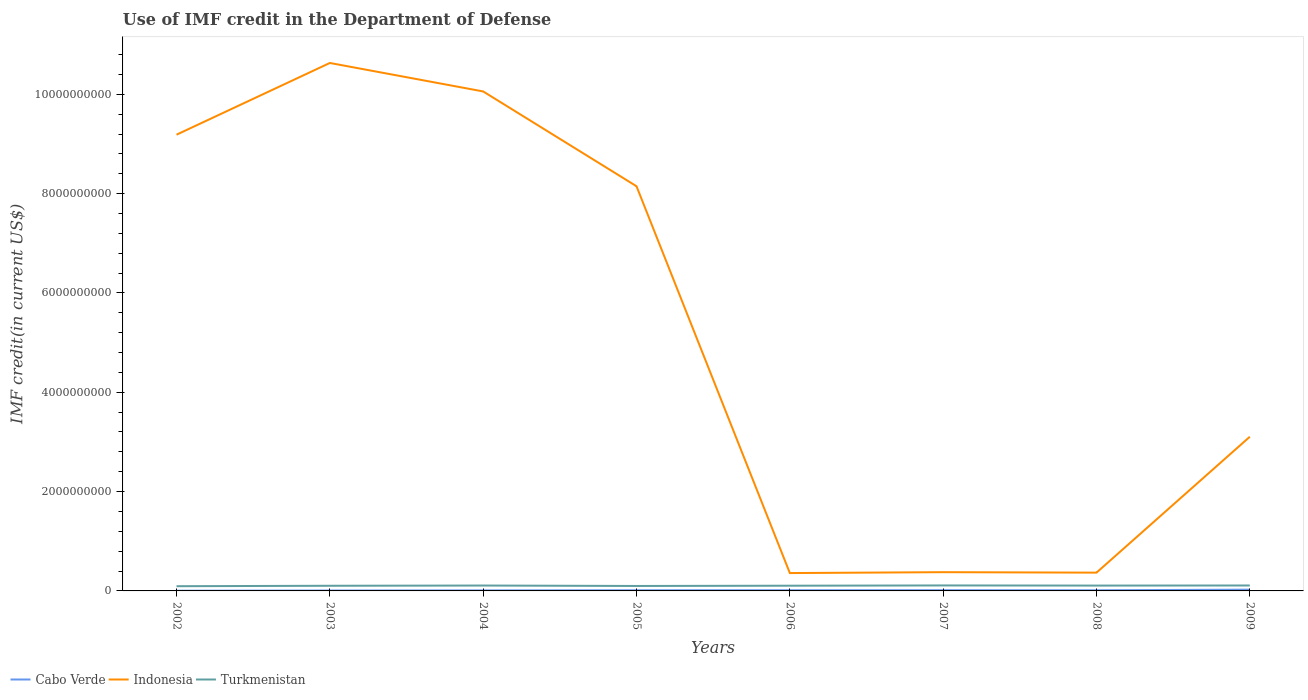Does the line corresponding to Indonesia intersect with the line corresponding to Turkmenistan?
Provide a short and direct response. No. Is the number of lines equal to the number of legend labels?
Make the answer very short. Yes. Across all years, what is the maximum IMF credit in the Department of Defense in Turkmenistan?
Your response must be concise. 9.49e+07. In which year was the IMF credit in the Department of Defense in Indonesia maximum?
Give a very brief answer. 2006. What is the total IMF credit in the Department of Defense in Indonesia in the graph?
Ensure brevity in your answer.  9.69e+09. What is the difference between the highest and the second highest IMF credit in the Department of Defense in Cabo Verde?
Your response must be concise. 2.12e+07. Is the IMF credit in the Department of Defense in Cabo Verde strictly greater than the IMF credit in the Department of Defense in Indonesia over the years?
Your answer should be very brief. Yes. How many lines are there?
Keep it short and to the point. 3. How many years are there in the graph?
Ensure brevity in your answer.  8. Are the values on the major ticks of Y-axis written in scientific E-notation?
Your response must be concise. No. Does the graph contain any zero values?
Keep it short and to the point. No. Does the graph contain grids?
Make the answer very short. No. What is the title of the graph?
Your answer should be very brief. Use of IMF credit in the Department of Defense. Does "San Marino" appear as one of the legend labels in the graph?
Provide a short and direct response. No. What is the label or title of the Y-axis?
Ensure brevity in your answer.  IMF credit(in current US$). What is the IMF credit(in current US$) in Cabo Verde in 2002?
Provide a short and direct response. 4.19e+06. What is the IMF credit(in current US$) in Indonesia in 2002?
Your answer should be compact. 9.19e+09. What is the IMF credit(in current US$) in Turkmenistan in 2002?
Provide a short and direct response. 9.49e+07. What is the IMF credit(in current US$) of Cabo Verde in 2003?
Your response must be concise. 8.23e+06. What is the IMF credit(in current US$) in Indonesia in 2003?
Provide a succinct answer. 1.06e+1. What is the IMF credit(in current US$) of Turkmenistan in 2003?
Give a very brief answer. 1.04e+08. What is the IMF credit(in current US$) in Cabo Verde in 2004?
Give a very brief answer. 1.05e+07. What is the IMF credit(in current US$) in Indonesia in 2004?
Offer a terse response. 1.01e+1. What is the IMF credit(in current US$) of Turkmenistan in 2004?
Provide a succinct answer. 1.08e+08. What is the IMF credit(in current US$) in Cabo Verde in 2005?
Make the answer very short. 1.32e+07. What is the IMF credit(in current US$) of Indonesia in 2005?
Your answer should be compact. 8.15e+09. What is the IMF credit(in current US$) of Turkmenistan in 2005?
Keep it short and to the point. 9.98e+07. What is the IMF credit(in current US$) in Cabo Verde in 2006?
Your answer should be compact. 1.39e+07. What is the IMF credit(in current US$) of Indonesia in 2006?
Ensure brevity in your answer.  3.59e+08. What is the IMF credit(in current US$) of Turkmenistan in 2006?
Provide a short and direct response. 1.05e+08. What is the IMF credit(in current US$) in Cabo Verde in 2007?
Provide a succinct answer. 1.44e+07. What is the IMF credit(in current US$) of Indonesia in 2007?
Your response must be concise. 3.78e+08. What is the IMF credit(in current US$) in Turkmenistan in 2007?
Ensure brevity in your answer.  1.10e+08. What is the IMF credit(in current US$) of Cabo Verde in 2008?
Your answer should be very brief. 1.33e+07. What is the IMF credit(in current US$) of Indonesia in 2008?
Your answer should be very brief. 3.68e+08. What is the IMF credit(in current US$) of Turkmenistan in 2008?
Make the answer very short. 1.08e+08. What is the IMF credit(in current US$) of Cabo Verde in 2009?
Your answer should be compact. 2.54e+07. What is the IMF credit(in current US$) of Indonesia in 2009?
Give a very brief answer. 3.10e+09. What is the IMF credit(in current US$) of Turkmenistan in 2009?
Ensure brevity in your answer.  1.09e+08. Across all years, what is the maximum IMF credit(in current US$) of Cabo Verde?
Provide a succinct answer. 2.54e+07. Across all years, what is the maximum IMF credit(in current US$) of Indonesia?
Offer a terse response. 1.06e+1. Across all years, what is the maximum IMF credit(in current US$) in Turkmenistan?
Your answer should be very brief. 1.10e+08. Across all years, what is the minimum IMF credit(in current US$) in Cabo Verde?
Offer a terse response. 4.19e+06. Across all years, what is the minimum IMF credit(in current US$) in Indonesia?
Ensure brevity in your answer.  3.59e+08. Across all years, what is the minimum IMF credit(in current US$) in Turkmenistan?
Ensure brevity in your answer.  9.49e+07. What is the total IMF credit(in current US$) of Cabo Verde in the graph?
Your answer should be very brief. 1.03e+08. What is the total IMF credit(in current US$) of Indonesia in the graph?
Keep it short and to the point. 4.22e+1. What is the total IMF credit(in current US$) in Turkmenistan in the graph?
Offer a terse response. 8.39e+08. What is the difference between the IMF credit(in current US$) in Cabo Verde in 2002 and that in 2003?
Your answer should be compact. -4.04e+06. What is the difference between the IMF credit(in current US$) of Indonesia in 2002 and that in 2003?
Provide a succinct answer. -1.44e+09. What is the difference between the IMF credit(in current US$) in Turkmenistan in 2002 and that in 2003?
Your response must be concise. -8.83e+06. What is the difference between the IMF credit(in current US$) of Cabo Verde in 2002 and that in 2004?
Make the answer very short. -6.33e+06. What is the difference between the IMF credit(in current US$) in Indonesia in 2002 and that in 2004?
Give a very brief answer. -8.71e+08. What is the difference between the IMF credit(in current US$) in Turkmenistan in 2002 and that in 2004?
Your answer should be very brief. -1.35e+07. What is the difference between the IMF credit(in current US$) of Cabo Verde in 2002 and that in 2005?
Your answer should be compact. -9.05e+06. What is the difference between the IMF credit(in current US$) in Indonesia in 2002 and that in 2005?
Your answer should be compact. 1.04e+09. What is the difference between the IMF credit(in current US$) of Turkmenistan in 2002 and that in 2005?
Your answer should be very brief. -4.87e+06. What is the difference between the IMF credit(in current US$) of Cabo Verde in 2002 and that in 2006?
Your answer should be very brief. -9.74e+06. What is the difference between the IMF credit(in current US$) of Indonesia in 2002 and that in 2006?
Your answer should be compact. 8.83e+09. What is the difference between the IMF credit(in current US$) in Turkmenistan in 2002 and that in 2006?
Keep it short and to the point. -1.01e+07. What is the difference between the IMF credit(in current US$) of Cabo Verde in 2002 and that in 2007?
Ensure brevity in your answer.  -1.03e+07. What is the difference between the IMF credit(in current US$) in Indonesia in 2002 and that in 2007?
Your response must be concise. 8.81e+09. What is the difference between the IMF credit(in current US$) of Turkmenistan in 2002 and that in 2007?
Keep it short and to the point. -1.54e+07. What is the difference between the IMF credit(in current US$) of Cabo Verde in 2002 and that in 2008?
Give a very brief answer. -9.13e+06. What is the difference between the IMF credit(in current US$) of Indonesia in 2002 and that in 2008?
Offer a very short reply. 8.82e+09. What is the difference between the IMF credit(in current US$) in Turkmenistan in 2002 and that in 2008?
Your answer should be very brief. -1.26e+07. What is the difference between the IMF credit(in current US$) in Cabo Verde in 2002 and that in 2009?
Make the answer very short. -2.12e+07. What is the difference between the IMF credit(in current US$) in Indonesia in 2002 and that in 2009?
Give a very brief answer. 6.08e+09. What is the difference between the IMF credit(in current US$) in Turkmenistan in 2002 and that in 2009?
Give a very brief answer. -1.45e+07. What is the difference between the IMF credit(in current US$) in Cabo Verde in 2003 and that in 2004?
Provide a succinct answer. -2.28e+06. What is the difference between the IMF credit(in current US$) in Indonesia in 2003 and that in 2004?
Keep it short and to the point. 5.73e+08. What is the difference between the IMF credit(in current US$) of Turkmenistan in 2003 and that in 2004?
Offer a very short reply. -4.68e+06. What is the difference between the IMF credit(in current US$) of Cabo Verde in 2003 and that in 2005?
Give a very brief answer. -5.00e+06. What is the difference between the IMF credit(in current US$) in Indonesia in 2003 and that in 2005?
Your answer should be compact. 2.48e+09. What is the difference between the IMF credit(in current US$) in Turkmenistan in 2003 and that in 2005?
Provide a succinct answer. 3.96e+06. What is the difference between the IMF credit(in current US$) in Cabo Verde in 2003 and that in 2006?
Your answer should be very brief. -5.70e+06. What is the difference between the IMF credit(in current US$) in Indonesia in 2003 and that in 2006?
Keep it short and to the point. 1.03e+1. What is the difference between the IMF credit(in current US$) of Turkmenistan in 2003 and that in 2006?
Ensure brevity in your answer.  -1.29e+06. What is the difference between the IMF credit(in current US$) of Cabo Verde in 2003 and that in 2007?
Offer a very short reply. -6.21e+06. What is the difference between the IMF credit(in current US$) in Indonesia in 2003 and that in 2007?
Your response must be concise. 1.03e+1. What is the difference between the IMF credit(in current US$) in Turkmenistan in 2003 and that in 2007?
Ensure brevity in your answer.  -6.58e+06. What is the difference between the IMF credit(in current US$) in Cabo Verde in 2003 and that in 2008?
Keep it short and to the point. -5.08e+06. What is the difference between the IMF credit(in current US$) of Indonesia in 2003 and that in 2008?
Your answer should be compact. 1.03e+1. What is the difference between the IMF credit(in current US$) of Turkmenistan in 2003 and that in 2008?
Offer a terse response. -3.79e+06. What is the difference between the IMF credit(in current US$) of Cabo Verde in 2003 and that in 2009?
Your answer should be very brief. -1.72e+07. What is the difference between the IMF credit(in current US$) of Indonesia in 2003 and that in 2009?
Provide a succinct answer. 7.53e+09. What is the difference between the IMF credit(in current US$) in Turkmenistan in 2003 and that in 2009?
Give a very brief answer. -5.70e+06. What is the difference between the IMF credit(in current US$) in Cabo Verde in 2004 and that in 2005?
Make the answer very short. -2.72e+06. What is the difference between the IMF credit(in current US$) in Indonesia in 2004 and that in 2005?
Ensure brevity in your answer.  1.91e+09. What is the difference between the IMF credit(in current US$) in Turkmenistan in 2004 and that in 2005?
Your answer should be compact. 8.64e+06. What is the difference between the IMF credit(in current US$) in Cabo Verde in 2004 and that in 2006?
Provide a short and direct response. -3.42e+06. What is the difference between the IMF credit(in current US$) in Indonesia in 2004 and that in 2006?
Ensure brevity in your answer.  9.70e+09. What is the difference between the IMF credit(in current US$) in Turkmenistan in 2004 and that in 2006?
Your response must be concise. 3.39e+06. What is the difference between the IMF credit(in current US$) in Cabo Verde in 2004 and that in 2007?
Offer a terse response. -3.92e+06. What is the difference between the IMF credit(in current US$) of Indonesia in 2004 and that in 2007?
Offer a terse response. 9.68e+09. What is the difference between the IMF credit(in current US$) of Turkmenistan in 2004 and that in 2007?
Ensure brevity in your answer.  -1.90e+06. What is the difference between the IMF credit(in current US$) in Cabo Verde in 2004 and that in 2008?
Make the answer very short. -2.80e+06. What is the difference between the IMF credit(in current US$) of Indonesia in 2004 and that in 2008?
Ensure brevity in your answer.  9.69e+09. What is the difference between the IMF credit(in current US$) of Turkmenistan in 2004 and that in 2008?
Make the answer very short. 8.89e+05. What is the difference between the IMF credit(in current US$) of Cabo Verde in 2004 and that in 2009?
Provide a succinct answer. -1.49e+07. What is the difference between the IMF credit(in current US$) of Indonesia in 2004 and that in 2009?
Your answer should be very brief. 6.95e+09. What is the difference between the IMF credit(in current US$) of Turkmenistan in 2004 and that in 2009?
Provide a succinct answer. -1.02e+06. What is the difference between the IMF credit(in current US$) in Cabo Verde in 2005 and that in 2006?
Your response must be concise. -6.96e+05. What is the difference between the IMF credit(in current US$) in Indonesia in 2005 and that in 2006?
Provide a short and direct response. 7.79e+09. What is the difference between the IMF credit(in current US$) in Turkmenistan in 2005 and that in 2006?
Offer a very short reply. -5.24e+06. What is the difference between the IMF credit(in current US$) of Cabo Verde in 2005 and that in 2007?
Offer a terse response. -1.20e+06. What is the difference between the IMF credit(in current US$) of Indonesia in 2005 and that in 2007?
Provide a succinct answer. 7.77e+09. What is the difference between the IMF credit(in current US$) in Turkmenistan in 2005 and that in 2007?
Your answer should be very brief. -1.05e+07. What is the difference between the IMF credit(in current US$) of Cabo Verde in 2005 and that in 2008?
Your response must be concise. -8.10e+04. What is the difference between the IMF credit(in current US$) of Indonesia in 2005 and that in 2008?
Keep it short and to the point. 7.78e+09. What is the difference between the IMF credit(in current US$) of Turkmenistan in 2005 and that in 2008?
Your answer should be very brief. -7.75e+06. What is the difference between the IMF credit(in current US$) of Cabo Verde in 2005 and that in 2009?
Offer a very short reply. -1.22e+07. What is the difference between the IMF credit(in current US$) of Indonesia in 2005 and that in 2009?
Provide a short and direct response. 5.04e+09. What is the difference between the IMF credit(in current US$) of Turkmenistan in 2005 and that in 2009?
Make the answer very short. -9.66e+06. What is the difference between the IMF credit(in current US$) of Cabo Verde in 2006 and that in 2007?
Your answer should be compact. -5.08e+05. What is the difference between the IMF credit(in current US$) in Indonesia in 2006 and that in 2007?
Give a very brief answer. -1.81e+07. What is the difference between the IMF credit(in current US$) of Turkmenistan in 2006 and that in 2007?
Ensure brevity in your answer.  -5.30e+06. What is the difference between the IMF credit(in current US$) of Cabo Verde in 2006 and that in 2008?
Your answer should be very brief. 6.15e+05. What is the difference between the IMF credit(in current US$) of Indonesia in 2006 and that in 2008?
Your answer should be compact. -8.57e+06. What is the difference between the IMF credit(in current US$) of Turkmenistan in 2006 and that in 2008?
Keep it short and to the point. -2.50e+06. What is the difference between the IMF credit(in current US$) in Cabo Verde in 2006 and that in 2009?
Offer a terse response. -1.15e+07. What is the difference between the IMF credit(in current US$) of Indonesia in 2006 and that in 2009?
Provide a succinct answer. -2.75e+09. What is the difference between the IMF credit(in current US$) in Turkmenistan in 2006 and that in 2009?
Offer a very short reply. -4.42e+06. What is the difference between the IMF credit(in current US$) in Cabo Verde in 2007 and that in 2008?
Offer a very short reply. 1.12e+06. What is the difference between the IMF credit(in current US$) in Indonesia in 2007 and that in 2008?
Offer a terse response. 9.55e+06. What is the difference between the IMF credit(in current US$) of Turkmenistan in 2007 and that in 2008?
Your answer should be very brief. 2.79e+06. What is the difference between the IMF credit(in current US$) in Cabo Verde in 2007 and that in 2009?
Your answer should be very brief. -1.10e+07. What is the difference between the IMF credit(in current US$) in Indonesia in 2007 and that in 2009?
Provide a succinct answer. -2.73e+09. What is the difference between the IMF credit(in current US$) in Turkmenistan in 2007 and that in 2009?
Your answer should be compact. 8.77e+05. What is the difference between the IMF credit(in current US$) of Cabo Verde in 2008 and that in 2009?
Ensure brevity in your answer.  -1.21e+07. What is the difference between the IMF credit(in current US$) of Indonesia in 2008 and that in 2009?
Offer a very short reply. -2.74e+09. What is the difference between the IMF credit(in current US$) in Turkmenistan in 2008 and that in 2009?
Your answer should be compact. -1.91e+06. What is the difference between the IMF credit(in current US$) of Cabo Verde in 2002 and the IMF credit(in current US$) of Indonesia in 2003?
Your answer should be compact. -1.06e+1. What is the difference between the IMF credit(in current US$) in Cabo Verde in 2002 and the IMF credit(in current US$) in Turkmenistan in 2003?
Give a very brief answer. -9.96e+07. What is the difference between the IMF credit(in current US$) of Indonesia in 2002 and the IMF credit(in current US$) of Turkmenistan in 2003?
Your response must be concise. 9.08e+09. What is the difference between the IMF credit(in current US$) of Cabo Verde in 2002 and the IMF credit(in current US$) of Indonesia in 2004?
Provide a short and direct response. -1.01e+1. What is the difference between the IMF credit(in current US$) in Cabo Verde in 2002 and the IMF credit(in current US$) in Turkmenistan in 2004?
Keep it short and to the point. -1.04e+08. What is the difference between the IMF credit(in current US$) of Indonesia in 2002 and the IMF credit(in current US$) of Turkmenistan in 2004?
Make the answer very short. 9.08e+09. What is the difference between the IMF credit(in current US$) in Cabo Verde in 2002 and the IMF credit(in current US$) in Indonesia in 2005?
Provide a succinct answer. -8.14e+09. What is the difference between the IMF credit(in current US$) in Cabo Verde in 2002 and the IMF credit(in current US$) in Turkmenistan in 2005?
Provide a succinct answer. -9.56e+07. What is the difference between the IMF credit(in current US$) of Indonesia in 2002 and the IMF credit(in current US$) of Turkmenistan in 2005?
Ensure brevity in your answer.  9.09e+09. What is the difference between the IMF credit(in current US$) of Cabo Verde in 2002 and the IMF credit(in current US$) of Indonesia in 2006?
Ensure brevity in your answer.  -3.55e+08. What is the difference between the IMF credit(in current US$) in Cabo Verde in 2002 and the IMF credit(in current US$) in Turkmenistan in 2006?
Your answer should be very brief. -1.01e+08. What is the difference between the IMF credit(in current US$) in Indonesia in 2002 and the IMF credit(in current US$) in Turkmenistan in 2006?
Make the answer very short. 9.08e+09. What is the difference between the IMF credit(in current US$) of Cabo Verde in 2002 and the IMF credit(in current US$) of Indonesia in 2007?
Your answer should be very brief. -3.73e+08. What is the difference between the IMF credit(in current US$) of Cabo Verde in 2002 and the IMF credit(in current US$) of Turkmenistan in 2007?
Your answer should be compact. -1.06e+08. What is the difference between the IMF credit(in current US$) in Indonesia in 2002 and the IMF credit(in current US$) in Turkmenistan in 2007?
Your response must be concise. 9.08e+09. What is the difference between the IMF credit(in current US$) in Cabo Verde in 2002 and the IMF credit(in current US$) in Indonesia in 2008?
Offer a very short reply. -3.64e+08. What is the difference between the IMF credit(in current US$) of Cabo Verde in 2002 and the IMF credit(in current US$) of Turkmenistan in 2008?
Keep it short and to the point. -1.03e+08. What is the difference between the IMF credit(in current US$) in Indonesia in 2002 and the IMF credit(in current US$) in Turkmenistan in 2008?
Keep it short and to the point. 9.08e+09. What is the difference between the IMF credit(in current US$) in Cabo Verde in 2002 and the IMF credit(in current US$) in Indonesia in 2009?
Keep it short and to the point. -3.10e+09. What is the difference between the IMF credit(in current US$) in Cabo Verde in 2002 and the IMF credit(in current US$) in Turkmenistan in 2009?
Ensure brevity in your answer.  -1.05e+08. What is the difference between the IMF credit(in current US$) in Indonesia in 2002 and the IMF credit(in current US$) in Turkmenistan in 2009?
Provide a succinct answer. 9.08e+09. What is the difference between the IMF credit(in current US$) of Cabo Verde in 2003 and the IMF credit(in current US$) of Indonesia in 2004?
Provide a succinct answer. -1.00e+1. What is the difference between the IMF credit(in current US$) in Cabo Verde in 2003 and the IMF credit(in current US$) in Turkmenistan in 2004?
Provide a short and direct response. -1.00e+08. What is the difference between the IMF credit(in current US$) in Indonesia in 2003 and the IMF credit(in current US$) in Turkmenistan in 2004?
Keep it short and to the point. 1.05e+1. What is the difference between the IMF credit(in current US$) of Cabo Verde in 2003 and the IMF credit(in current US$) of Indonesia in 2005?
Offer a very short reply. -8.14e+09. What is the difference between the IMF credit(in current US$) in Cabo Verde in 2003 and the IMF credit(in current US$) in Turkmenistan in 2005?
Ensure brevity in your answer.  -9.16e+07. What is the difference between the IMF credit(in current US$) of Indonesia in 2003 and the IMF credit(in current US$) of Turkmenistan in 2005?
Give a very brief answer. 1.05e+1. What is the difference between the IMF credit(in current US$) in Cabo Verde in 2003 and the IMF credit(in current US$) in Indonesia in 2006?
Make the answer very short. -3.51e+08. What is the difference between the IMF credit(in current US$) of Cabo Verde in 2003 and the IMF credit(in current US$) of Turkmenistan in 2006?
Make the answer very short. -9.68e+07. What is the difference between the IMF credit(in current US$) in Indonesia in 2003 and the IMF credit(in current US$) in Turkmenistan in 2006?
Your answer should be very brief. 1.05e+1. What is the difference between the IMF credit(in current US$) in Cabo Verde in 2003 and the IMF credit(in current US$) in Indonesia in 2007?
Provide a short and direct response. -3.69e+08. What is the difference between the IMF credit(in current US$) in Cabo Verde in 2003 and the IMF credit(in current US$) in Turkmenistan in 2007?
Offer a terse response. -1.02e+08. What is the difference between the IMF credit(in current US$) of Indonesia in 2003 and the IMF credit(in current US$) of Turkmenistan in 2007?
Your response must be concise. 1.05e+1. What is the difference between the IMF credit(in current US$) of Cabo Verde in 2003 and the IMF credit(in current US$) of Indonesia in 2008?
Offer a terse response. -3.60e+08. What is the difference between the IMF credit(in current US$) of Cabo Verde in 2003 and the IMF credit(in current US$) of Turkmenistan in 2008?
Ensure brevity in your answer.  -9.93e+07. What is the difference between the IMF credit(in current US$) of Indonesia in 2003 and the IMF credit(in current US$) of Turkmenistan in 2008?
Provide a short and direct response. 1.05e+1. What is the difference between the IMF credit(in current US$) of Cabo Verde in 2003 and the IMF credit(in current US$) of Indonesia in 2009?
Give a very brief answer. -3.10e+09. What is the difference between the IMF credit(in current US$) in Cabo Verde in 2003 and the IMF credit(in current US$) in Turkmenistan in 2009?
Your answer should be compact. -1.01e+08. What is the difference between the IMF credit(in current US$) in Indonesia in 2003 and the IMF credit(in current US$) in Turkmenistan in 2009?
Your response must be concise. 1.05e+1. What is the difference between the IMF credit(in current US$) of Cabo Verde in 2004 and the IMF credit(in current US$) of Indonesia in 2005?
Give a very brief answer. -8.14e+09. What is the difference between the IMF credit(in current US$) of Cabo Verde in 2004 and the IMF credit(in current US$) of Turkmenistan in 2005?
Your answer should be very brief. -8.93e+07. What is the difference between the IMF credit(in current US$) in Indonesia in 2004 and the IMF credit(in current US$) in Turkmenistan in 2005?
Keep it short and to the point. 9.96e+09. What is the difference between the IMF credit(in current US$) in Cabo Verde in 2004 and the IMF credit(in current US$) in Indonesia in 2006?
Provide a succinct answer. -3.49e+08. What is the difference between the IMF credit(in current US$) of Cabo Verde in 2004 and the IMF credit(in current US$) of Turkmenistan in 2006?
Offer a terse response. -9.45e+07. What is the difference between the IMF credit(in current US$) of Indonesia in 2004 and the IMF credit(in current US$) of Turkmenistan in 2006?
Make the answer very short. 9.95e+09. What is the difference between the IMF credit(in current US$) in Cabo Verde in 2004 and the IMF credit(in current US$) in Indonesia in 2007?
Keep it short and to the point. -3.67e+08. What is the difference between the IMF credit(in current US$) of Cabo Verde in 2004 and the IMF credit(in current US$) of Turkmenistan in 2007?
Provide a short and direct response. -9.98e+07. What is the difference between the IMF credit(in current US$) in Indonesia in 2004 and the IMF credit(in current US$) in Turkmenistan in 2007?
Provide a succinct answer. 9.95e+09. What is the difference between the IMF credit(in current US$) in Cabo Verde in 2004 and the IMF credit(in current US$) in Indonesia in 2008?
Give a very brief answer. -3.58e+08. What is the difference between the IMF credit(in current US$) of Cabo Verde in 2004 and the IMF credit(in current US$) of Turkmenistan in 2008?
Keep it short and to the point. -9.70e+07. What is the difference between the IMF credit(in current US$) in Indonesia in 2004 and the IMF credit(in current US$) in Turkmenistan in 2008?
Keep it short and to the point. 9.95e+09. What is the difference between the IMF credit(in current US$) in Cabo Verde in 2004 and the IMF credit(in current US$) in Indonesia in 2009?
Ensure brevity in your answer.  -3.09e+09. What is the difference between the IMF credit(in current US$) of Cabo Verde in 2004 and the IMF credit(in current US$) of Turkmenistan in 2009?
Make the answer very short. -9.89e+07. What is the difference between the IMF credit(in current US$) of Indonesia in 2004 and the IMF credit(in current US$) of Turkmenistan in 2009?
Give a very brief answer. 9.95e+09. What is the difference between the IMF credit(in current US$) of Cabo Verde in 2005 and the IMF credit(in current US$) of Indonesia in 2006?
Your answer should be compact. -3.46e+08. What is the difference between the IMF credit(in current US$) of Cabo Verde in 2005 and the IMF credit(in current US$) of Turkmenistan in 2006?
Provide a short and direct response. -9.18e+07. What is the difference between the IMF credit(in current US$) of Indonesia in 2005 and the IMF credit(in current US$) of Turkmenistan in 2006?
Offer a terse response. 8.04e+09. What is the difference between the IMF credit(in current US$) of Cabo Verde in 2005 and the IMF credit(in current US$) of Indonesia in 2007?
Ensure brevity in your answer.  -3.64e+08. What is the difference between the IMF credit(in current US$) in Cabo Verde in 2005 and the IMF credit(in current US$) in Turkmenistan in 2007?
Provide a short and direct response. -9.71e+07. What is the difference between the IMF credit(in current US$) in Indonesia in 2005 and the IMF credit(in current US$) in Turkmenistan in 2007?
Make the answer very short. 8.04e+09. What is the difference between the IMF credit(in current US$) of Cabo Verde in 2005 and the IMF credit(in current US$) of Indonesia in 2008?
Your answer should be compact. -3.55e+08. What is the difference between the IMF credit(in current US$) of Cabo Verde in 2005 and the IMF credit(in current US$) of Turkmenistan in 2008?
Your answer should be compact. -9.43e+07. What is the difference between the IMF credit(in current US$) in Indonesia in 2005 and the IMF credit(in current US$) in Turkmenistan in 2008?
Give a very brief answer. 8.04e+09. What is the difference between the IMF credit(in current US$) in Cabo Verde in 2005 and the IMF credit(in current US$) in Indonesia in 2009?
Offer a very short reply. -3.09e+09. What is the difference between the IMF credit(in current US$) in Cabo Verde in 2005 and the IMF credit(in current US$) in Turkmenistan in 2009?
Offer a terse response. -9.62e+07. What is the difference between the IMF credit(in current US$) in Indonesia in 2005 and the IMF credit(in current US$) in Turkmenistan in 2009?
Offer a very short reply. 8.04e+09. What is the difference between the IMF credit(in current US$) in Cabo Verde in 2006 and the IMF credit(in current US$) in Indonesia in 2007?
Your answer should be very brief. -3.64e+08. What is the difference between the IMF credit(in current US$) of Cabo Verde in 2006 and the IMF credit(in current US$) of Turkmenistan in 2007?
Ensure brevity in your answer.  -9.64e+07. What is the difference between the IMF credit(in current US$) of Indonesia in 2006 and the IMF credit(in current US$) of Turkmenistan in 2007?
Make the answer very short. 2.49e+08. What is the difference between the IMF credit(in current US$) in Cabo Verde in 2006 and the IMF credit(in current US$) in Indonesia in 2008?
Offer a terse response. -3.54e+08. What is the difference between the IMF credit(in current US$) in Cabo Verde in 2006 and the IMF credit(in current US$) in Turkmenistan in 2008?
Your answer should be very brief. -9.36e+07. What is the difference between the IMF credit(in current US$) in Indonesia in 2006 and the IMF credit(in current US$) in Turkmenistan in 2008?
Ensure brevity in your answer.  2.52e+08. What is the difference between the IMF credit(in current US$) of Cabo Verde in 2006 and the IMF credit(in current US$) of Indonesia in 2009?
Ensure brevity in your answer.  -3.09e+09. What is the difference between the IMF credit(in current US$) in Cabo Verde in 2006 and the IMF credit(in current US$) in Turkmenistan in 2009?
Your answer should be very brief. -9.55e+07. What is the difference between the IMF credit(in current US$) of Indonesia in 2006 and the IMF credit(in current US$) of Turkmenistan in 2009?
Give a very brief answer. 2.50e+08. What is the difference between the IMF credit(in current US$) of Cabo Verde in 2007 and the IMF credit(in current US$) of Indonesia in 2008?
Ensure brevity in your answer.  -3.54e+08. What is the difference between the IMF credit(in current US$) of Cabo Verde in 2007 and the IMF credit(in current US$) of Turkmenistan in 2008?
Your response must be concise. -9.31e+07. What is the difference between the IMF credit(in current US$) in Indonesia in 2007 and the IMF credit(in current US$) in Turkmenistan in 2008?
Your answer should be very brief. 2.70e+08. What is the difference between the IMF credit(in current US$) of Cabo Verde in 2007 and the IMF credit(in current US$) of Indonesia in 2009?
Provide a succinct answer. -3.09e+09. What is the difference between the IMF credit(in current US$) of Cabo Verde in 2007 and the IMF credit(in current US$) of Turkmenistan in 2009?
Keep it short and to the point. -9.50e+07. What is the difference between the IMF credit(in current US$) in Indonesia in 2007 and the IMF credit(in current US$) in Turkmenistan in 2009?
Ensure brevity in your answer.  2.68e+08. What is the difference between the IMF credit(in current US$) of Cabo Verde in 2008 and the IMF credit(in current US$) of Indonesia in 2009?
Provide a short and direct response. -3.09e+09. What is the difference between the IMF credit(in current US$) of Cabo Verde in 2008 and the IMF credit(in current US$) of Turkmenistan in 2009?
Offer a terse response. -9.61e+07. What is the difference between the IMF credit(in current US$) in Indonesia in 2008 and the IMF credit(in current US$) in Turkmenistan in 2009?
Your answer should be compact. 2.59e+08. What is the average IMF credit(in current US$) of Cabo Verde per year?
Make the answer very short. 1.29e+07. What is the average IMF credit(in current US$) in Indonesia per year?
Give a very brief answer. 5.28e+09. What is the average IMF credit(in current US$) of Turkmenistan per year?
Make the answer very short. 1.05e+08. In the year 2002, what is the difference between the IMF credit(in current US$) in Cabo Verde and IMF credit(in current US$) in Indonesia?
Ensure brevity in your answer.  -9.18e+09. In the year 2002, what is the difference between the IMF credit(in current US$) in Cabo Verde and IMF credit(in current US$) in Turkmenistan?
Your answer should be compact. -9.07e+07. In the year 2002, what is the difference between the IMF credit(in current US$) in Indonesia and IMF credit(in current US$) in Turkmenistan?
Keep it short and to the point. 9.09e+09. In the year 2003, what is the difference between the IMF credit(in current US$) in Cabo Verde and IMF credit(in current US$) in Indonesia?
Your answer should be very brief. -1.06e+1. In the year 2003, what is the difference between the IMF credit(in current US$) of Cabo Verde and IMF credit(in current US$) of Turkmenistan?
Offer a terse response. -9.55e+07. In the year 2003, what is the difference between the IMF credit(in current US$) in Indonesia and IMF credit(in current US$) in Turkmenistan?
Ensure brevity in your answer.  1.05e+1. In the year 2004, what is the difference between the IMF credit(in current US$) of Cabo Verde and IMF credit(in current US$) of Indonesia?
Offer a very short reply. -1.00e+1. In the year 2004, what is the difference between the IMF credit(in current US$) in Cabo Verde and IMF credit(in current US$) in Turkmenistan?
Provide a succinct answer. -9.79e+07. In the year 2004, what is the difference between the IMF credit(in current US$) of Indonesia and IMF credit(in current US$) of Turkmenistan?
Your answer should be compact. 9.95e+09. In the year 2005, what is the difference between the IMF credit(in current US$) of Cabo Verde and IMF credit(in current US$) of Indonesia?
Provide a succinct answer. -8.14e+09. In the year 2005, what is the difference between the IMF credit(in current US$) of Cabo Verde and IMF credit(in current US$) of Turkmenistan?
Ensure brevity in your answer.  -8.66e+07. In the year 2005, what is the difference between the IMF credit(in current US$) in Indonesia and IMF credit(in current US$) in Turkmenistan?
Make the answer very short. 8.05e+09. In the year 2006, what is the difference between the IMF credit(in current US$) of Cabo Verde and IMF credit(in current US$) of Indonesia?
Offer a very short reply. -3.46e+08. In the year 2006, what is the difference between the IMF credit(in current US$) in Cabo Verde and IMF credit(in current US$) in Turkmenistan?
Your response must be concise. -9.11e+07. In the year 2006, what is the difference between the IMF credit(in current US$) in Indonesia and IMF credit(in current US$) in Turkmenistan?
Make the answer very short. 2.54e+08. In the year 2007, what is the difference between the IMF credit(in current US$) of Cabo Verde and IMF credit(in current US$) of Indonesia?
Your answer should be compact. -3.63e+08. In the year 2007, what is the difference between the IMF credit(in current US$) of Cabo Verde and IMF credit(in current US$) of Turkmenistan?
Ensure brevity in your answer.  -9.59e+07. In the year 2007, what is the difference between the IMF credit(in current US$) in Indonesia and IMF credit(in current US$) in Turkmenistan?
Your response must be concise. 2.67e+08. In the year 2008, what is the difference between the IMF credit(in current US$) in Cabo Verde and IMF credit(in current US$) in Indonesia?
Provide a short and direct response. -3.55e+08. In the year 2008, what is the difference between the IMF credit(in current US$) in Cabo Verde and IMF credit(in current US$) in Turkmenistan?
Offer a terse response. -9.42e+07. In the year 2008, what is the difference between the IMF credit(in current US$) in Indonesia and IMF credit(in current US$) in Turkmenistan?
Ensure brevity in your answer.  2.61e+08. In the year 2009, what is the difference between the IMF credit(in current US$) in Cabo Verde and IMF credit(in current US$) in Indonesia?
Give a very brief answer. -3.08e+09. In the year 2009, what is the difference between the IMF credit(in current US$) in Cabo Verde and IMF credit(in current US$) in Turkmenistan?
Ensure brevity in your answer.  -8.40e+07. In the year 2009, what is the difference between the IMF credit(in current US$) in Indonesia and IMF credit(in current US$) in Turkmenistan?
Keep it short and to the point. 3.00e+09. What is the ratio of the IMF credit(in current US$) in Cabo Verde in 2002 to that in 2003?
Ensure brevity in your answer.  0.51. What is the ratio of the IMF credit(in current US$) in Indonesia in 2002 to that in 2003?
Make the answer very short. 0.86. What is the ratio of the IMF credit(in current US$) in Turkmenistan in 2002 to that in 2003?
Your response must be concise. 0.91. What is the ratio of the IMF credit(in current US$) of Cabo Verde in 2002 to that in 2004?
Give a very brief answer. 0.4. What is the ratio of the IMF credit(in current US$) in Indonesia in 2002 to that in 2004?
Your answer should be very brief. 0.91. What is the ratio of the IMF credit(in current US$) in Turkmenistan in 2002 to that in 2004?
Make the answer very short. 0.88. What is the ratio of the IMF credit(in current US$) of Cabo Verde in 2002 to that in 2005?
Your answer should be compact. 0.32. What is the ratio of the IMF credit(in current US$) of Indonesia in 2002 to that in 2005?
Make the answer very short. 1.13. What is the ratio of the IMF credit(in current US$) in Turkmenistan in 2002 to that in 2005?
Provide a short and direct response. 0.95. What is the ratio of the IMF credit(in current US$) of Cabo Verde in 2002 to that in 2006?
Your answer should be compact. 0.3. What is the ratio of the IMF credit(in current US$) of Indonesia in 2002 to that in 2006?
Keep it short and to the point. 25.55. What is the ratio of the IMF credit(in current US$) in Turkmenistan in 2002 to that in 2006?
Provide a succinct answer. 0.9. What is the ratio of the IMF credit(in current US$) of Cabo Verde in 2002 to that in 2007?
Your response must be concise. 0.29. What is the ratio of the IMF credit(in current US$) in Indonesia in 2002 to that in 2007?
Provide a short and direct response. 24.33. What is the ratio of the IMF credit(in current US$) of Turkmenistan in 2002 to that in 2007?
Provide a succinct answer. 0.86. What is the ratio of the IMF credit(in current US$) in Cabo Verde in 2002 to that in 2008?
Your answer should be compact. 0.31. What is the ratio of the IMF credit(in current US$) in Indonesia in 2002 to that in 2008?
Ensure brevity in your answer.  24.96. What is the ratio of the IMF credit(in current US$) in Turkmenistan in 2002 to that in 2008?
Give a very brief answer. 0.88. What is the ratio of the IMF credit(in current US$) of Cabo Verde in 2002 to that in 2009?
Offer a terse response. 0.16. What is the ratio of the IMF credit(in current US$) of Indonesia in 2002 to that in 2009?
Offer a very short reply. 2.96. What is the ratio of the IMF credit(in current US$) of Turkmenistan in 2002 to that in 2009?
Give a very brief answer. 0.87. What is the ratio of the IMF credit(in current US$) of Cabo Verde in 2003 to that in 2004?
Your response must be concise. 0.78. What is the ratio of the IMF credit(in current US$) in Indonesia in 2003 to that in 2004?
Keep it short and to the point. 1.06. What is the ratio of the IMF credit(in current US$) in Turkmenistan in 2003 to that in 2004?
Offer a terse response. 0.96. What is the ratio of the IMF credit(in current US$) in Cabo Verde in 2003 to that in 2005?
Make the answer very short. 0.62. What is the ratio of the IMF credit(in current US$) of Indonesia in 2003 to that in 2005?
Your answer should be compact. 1.3. What is the ratio of the IMF credit(in current US$) of Turkmenistan in 2003 to that in 2005?
Make the answer very short. 1.04. What is the ratio of the IMF credit(in current US$) of Cabo Verde in 2003 to that in 2006?
Offer a terse response. 0.59. What is the ratio of the IMF credit(in current US$) of Indonesia in 2003 to that in 2006?
Provide a short and direct response. 29.57. What is the ratio of the IMF credit(in current US$) of Cabo Verde in 2003 to that in 2007?
Offer a very short reply. 0.57. What is the ratio of the IMF credit(in current US$) in Indonesia in 2003 to that in 2007?
Your answer should be very brief. 28.15. What is the ratio of the IMF credit(in current US$) of Turkmenistan in 2003 to that in 2007?
Provide a short and direct response. 0.94. What is the ratio of the IMF credit(in current US$) of Cabo Verde in 2003 to that in 2008?
Keep it short and to the point. 0.62. What is the ratio of the IMF credit(in current US$) in Indonesia in 2003 to that in 2008?
Keep it short and to the point. 28.88. What is the ratio of the IMF credit(in current US$) in Turkmenistan in 2003 to that in 2008?
Your answer should be very brief. 0.96. What is the ratio of the IMF credit(in current US$) in Cabo Verde in 2003 to that in 2009?
Your answer should be compact. 0.32. What is the ratio of the IMF credit(in current US$) of Indonesia in 2003 to that in 2009?
Your answer should be compact. 3.42. What is the ratio of the IMF credit(in current US$) of Turkmenistan in 2003 to that in 2009?
Your response must be concise. 0.95. What is the ratio of the IMF credit(in current US$) in Cabo Verde in 2004 to that in 2005?
Provide a short and direct response. 0.79. What is the ratio of the IMF credit(in current US$) of Indonesia in 2004 to that in 2005?
Ensure brevity in your answer.  1.23. What is the ratio of the IMF credit(in current US$) of Turkmenistan in 2004 to that in 2005?
Offer a terse response. 1.09. What is the ratio of the IMF credit(in current US$) in Cabo Verde in 2004 to that in 2006?
Ensure brevity in your answer.  0.75. What is the ratio of the IMF credit(in current US$) of Indonesia in 2004 to that in 2006?
Your response must be concise. 27.98. What is the ratio of the IMF credit(in current US$) of Turkmenistan in 2004 to that in 2006?
Your answer should be compact. 1.03. What is the ratio of the IMF credit(in current US$) in Cabo Verde in 2004 to that in 2007?
Keep it short and to the point. 0.73. What is the ratio of the IMF credit(in current US$) of Indonesia in 2004 to that in 2007?
Provide a succinct answer. 26.63. What is the ratio of the IMF credit(in current US$) of Turkmenistan in 2004 to that in 2007?
Provide a succinct answer. 0.98. What is the ratio of the IMF credit(in current US$) in Cabo Verde in 2004 to that in 2008?
Keep it short and to the point. 0.79. What is the ratio of the IMF credit(in current US$) in Indonesia in 2004 to that in 2008?
Give a very brief answer. 27.33. What is the ratio of the IMF credit(in current US$) of Turkmenistan in 2004 to that in 2008?
Your response must be concise. 1.01. What is the ratio of the IMF credit(in current US$) in Cabo Verde in 2004 to that in 2009?
Give a very brief answer. 0.41. What is the ratio of the IMF credit(in current US$) in Indonesia in 2004 to that in 2009?
Provide a succinct answer. 3.24. What is the ratio of the IMF credit(in current US$) in Turkmenistan in 2004 to that in 2009?
Give a very brief answer. 0.99. What is the ratio of the IMF credit(in current US$) of Indonesia in 2005 to that in 2006?
Your response must be concise. 22.67. What is the ratio of the IMF credit(in current US$) in Turkmenistan in 2005 to that in 2006?
Give a very brief answer. 0.95. What is the ratio of the IMF credit(in current US$) in Cabo Verde in 2005 to that in 2007?
Keep it short and to the point. 0.92. What is the ratio of the IMF credit(in current US$) of Indonesia in 2005 to that in 2007?
Offer a very short reply. 21.58. What is the ratio of the IMF credit(in current US$) of Turkmenistan in 2005 to that in 2007?
Offer a very short reply. 0.9. What is the ratio of the IMF credit(in current US$) of Cabo Verde in 2005 to that in 2008?
Your answer should be compact. 0.99. What is the ratio of the IMF credit(in current US$) in Indonesia in 2005 to that in 2008?
Ensure brevity in your answer.  22.14. What is the ratio of the IMF credit(in current US$) of Turkmenistan in 2005 to that in 2008?
Give a very brief answer. 0.93. What is the ratio of the IMF credit(in current US$) in Cabo Verde in 2005 to that in 2009?
Keep it short and to the point. 0.52. What is the ratio of the IMF credit(in current US$) in Indonesia in 2005 to that in 2009?
Your response must be concise. 2.62. What is the ratio of the IMF credit(in current US$) in Turkmenistan in 2005 to that in 2009?
Offer a terse response. 0.91. What is the ratio of the IMF credit(in current US$) of Cabo Verde in 2006 to that in 2007?
Ensure brevity in your answer.  0.96. What is the ratio of the IMF credit(in current US$) of Turkmenistan in 2006 to that in 2007?
Offer a terse response. 0.95. What is the ratio of the IMF credit(in current US$) in Cabo Verde in 2006 to that in 2008?
Give a very brief answer. 1.05. What is the ratio of the IMF credit(in current US$) of Indonesia in 2006 to that in 2008?
Provide a short and direct response. 0.98. What is the ratio of the IMF credit(in current US$) in Turkmenistan in 2006 to that in 2008?
Your answer should be very brief. 0.98. What is the ratio of the IMF credit(in current US$) of Cabo Verde in 2006 to that in 2009?
Keep it short and to the point. 0.55. What is the ratio of the IMF credit(in current US$) in Indonesia in 2006 to that in 2009?
Provide a succinct answer. 0.12. What is the ratio of the IMF credit(in current US$) of Turkmenistan in 2006 to that in 2009?
Ensure brevity in your answer.  0.96. What is the ratio of the IMF credit(in current US$) in Cabo Verde in 2007 to that in 2008?
Your answer should be very brief. 1.08. What is the ratio of the IMF credit(in current US$) in Cabo Verde in 2007 to that in 2009?
Offer a terse response. 0.57. What is the ratio of the IMF credit(in current US$) in Indonesia in 2007 to that in 2009?
Keep it short and to the point. 0.12. What is the ratio of the IMF credit(in current US$) in Turkmenistan in 2007 to that in 2009?
Provide a succinct answer. 1.01. What is the ratio of the IMF credit(in current US$) of Cabo Verde in 2008 to that in 2009?
Ensure brevity in your answer.  0.52. What is the ratio of the IMF credit(in current US$) in Indonesia in 2008 to that in 2009?
Your answer should be very brief. 0.12. What is the ratio of the IMF credit(in current US$) in Turkmenistan in 2008 to that in 2009?
Provide a short and direct response. 0.98. What is the difference between the highest and the second highest IMF credit(in current US$) in Cabo Verde?
Offer a very short reply. 1.10e+07. What is the difference between the highest and the second highest IMF credit(in current US$) of Indonesia?
Your answer should be very brief. 5.73e+08. What is the difference between the highest and the second highest IMF credit(in current US$) in Turkmenistan?
Make the answer very short. 8.77e+05. What is the difference between the highest and the lowest IMF credit(in current US$) in Cabo Verde?
Keep it short and to the point. 2.12e+07. What is the difference between the highest and the lowest IMF credit(in current US$) in Indonesia?
Keep it short and to the point. 1.03e+1. What is the difference between the highest and the lowest IMF credit(in current US$) in Turkmenistan?
Your answer should be compact. 1.54e+07. 